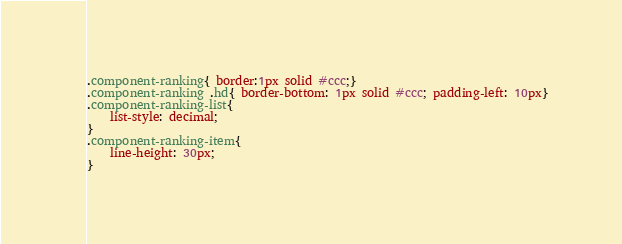Convert code to text. <code><loc_0><loc_0><loc_500><loc_500><_CSS_>.component-ranking{ border:1px solid #ccc;}
.component-ranking .hd{ border-bottom: 1px solid #ccc; padding-left: 10px}
.component-ranking-list{
    list-style: decimal;
}
.component-ranking-item{
    line-height: 30px;
}</code> 